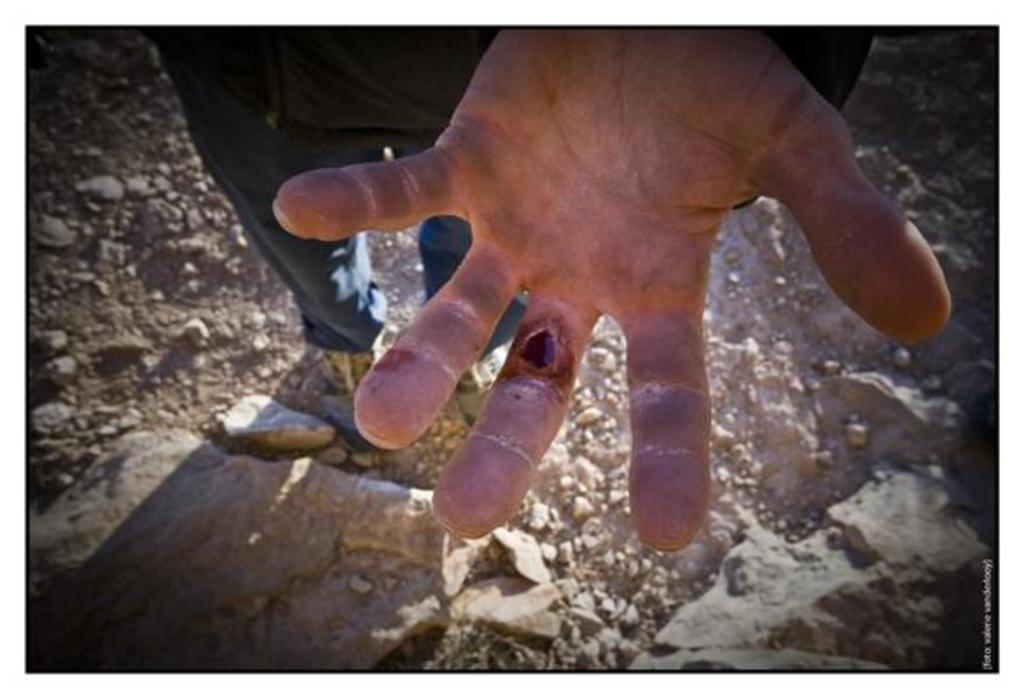What is the condition of the person's hand in the image? There is a person with a wound on their hand in the image. What can be seen beneath the person in the image? The ground is visible in the image. What type of objects are on the ground? There are stones on the ground. Where is the text located in the image? There is some text in the bottom right corner of the image. What arithmetic problem is the person trying to solve in the image? There is no arithmetic problem present in the image. Is the image set during the night or day? The time of day cannot be determined from the image, as there is no information about lighting or shadows. 